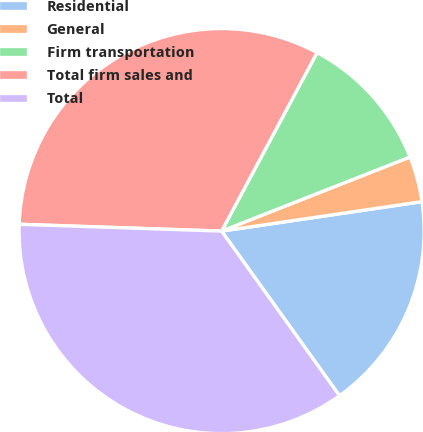<chart> <loc_0><loc_0><loc_500><loc_500><pie_chart><fcel>Residential<fcel>General<fcel>Firm transportation<fcel>Total firm sales and<fcel>Total<nl><fcel>17.43%<fcel>3.64%<fcel>11.22%<fcel>32.28%<fcel>35.43%<nl></chart> 